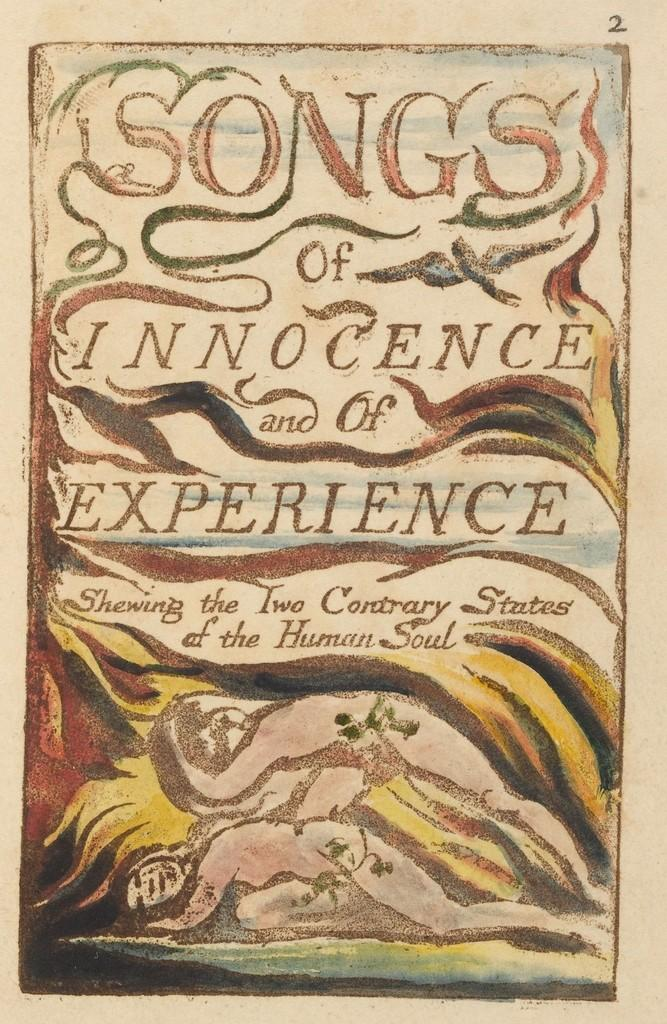Provide a one-sentence caption for the provided image. The book Songs of Innocence and of Experience sits on a table. 